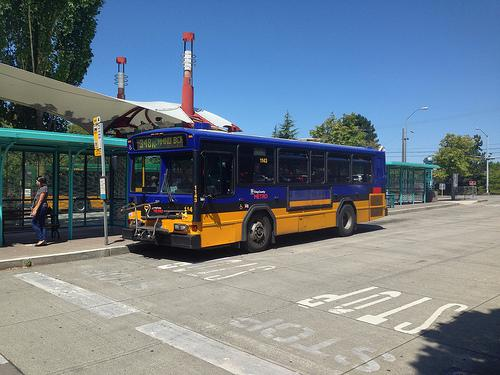Question: what time is it?
Choices:
A. Morning.
B. Noon.
C. Afternoon.
D. Midnight.
Answer with the letter. Answer: B Question: what is the weather like?
Choices:
A. Cloudy.
B. Windy.
C. Foggy.
D. Sunny.
Answer with the letter. Answer: D 